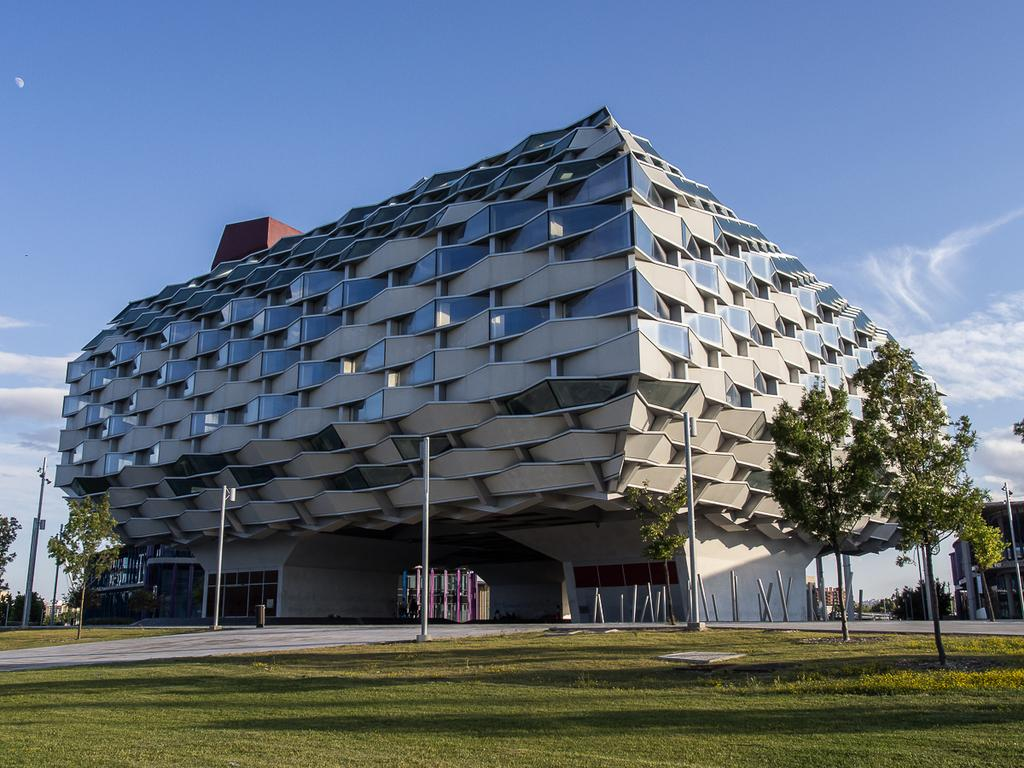What is the main structure in the center of the image? There is a building in the center of the image. What else can be seen in the image besides the building? There are poles, grass, trees, and sky visible in the image. Can you describe the vegetation in the image? There is grass at the bottom of the image and trees in the image. What is visible at the top of the image? There is sky visible at the top of the image. What is the temperature of the car in the image? There is no car present in the image, so it is not possible to determine the temperature. 